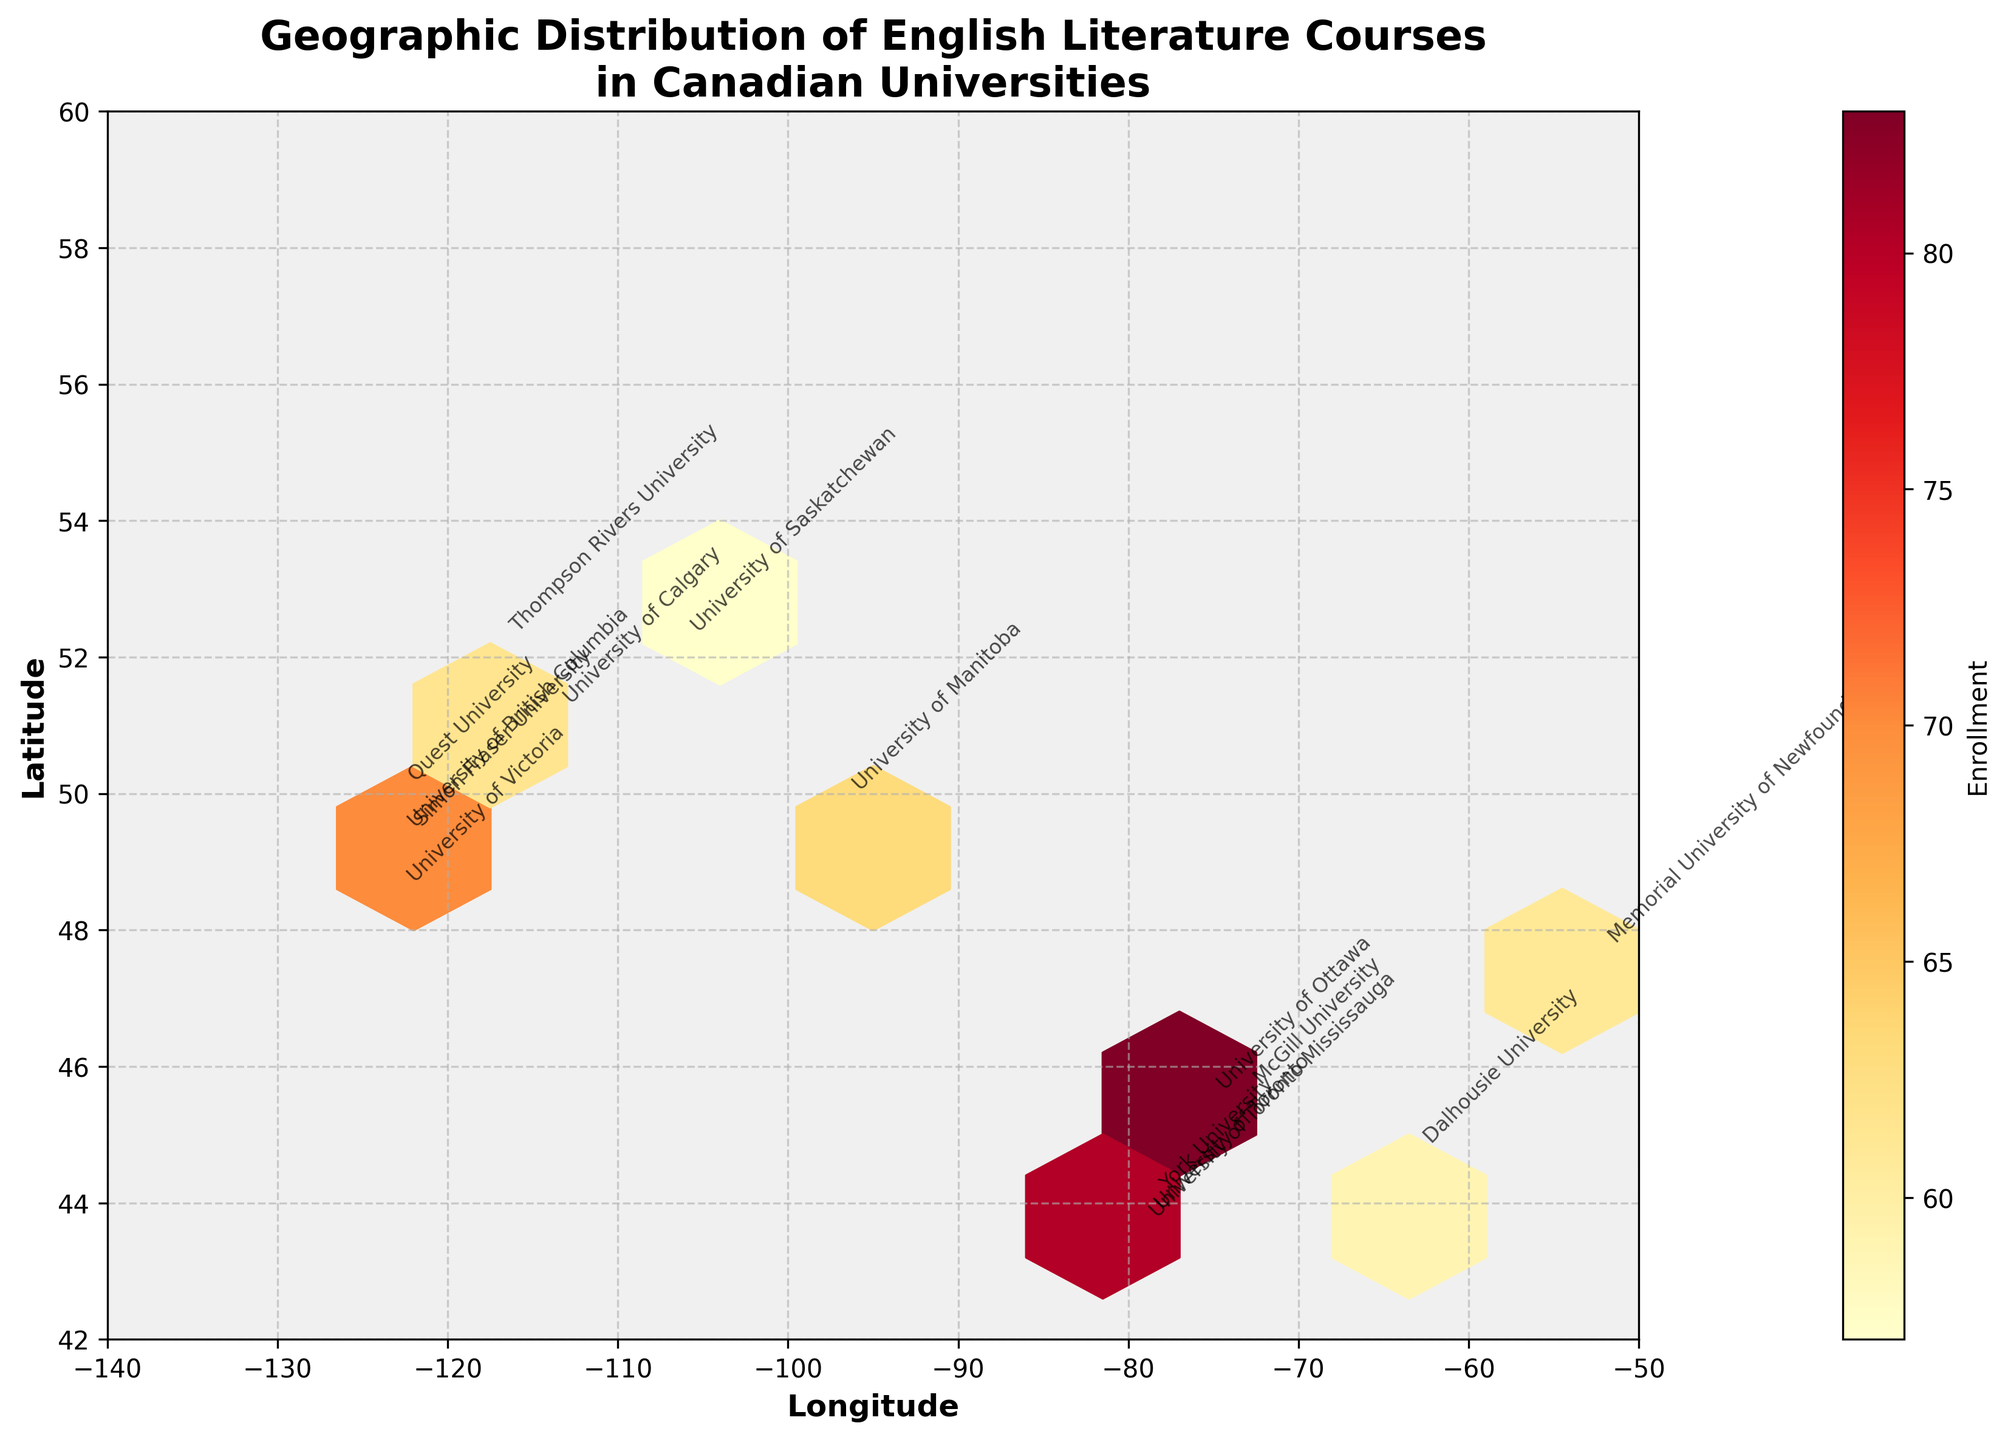What is the title of the figure? The title of a figure is typically located at the top and is usually styled to be more prominent. In this plot, the title is clearly written in bold at the top center.
Answer: Geographic Distribution of English Literature Courses in Canadian Universities How many universities are represented in the figure? The number of universities represented can be determined by counting the number of data points or annotations on the plot. Each university is uniquely annotated with its name.
Answer: 15 Which university has the highest enrollment for an English literature course? To identify the university with the highest enrollment, look for the annotation closest to the thickest hexagon, as the bin color intensity represents the enrollment number. Find the university name near the darkest red shade.
Answer: University of Toronto What is the color indicating the highest enrollment range in the color bar? The color bar provides a gradient of colors that represent different enrollment numbers. The darkest/highest color can be identified at the top end of the color bar.
Answer: Dark Red Which two universities have a similar longitude but different latitudes, and how do their enrollments compare? First, identify universities with similar longitudes by looking at the annotations along the same vertical line. Then compare their latitudes and associated enrollment numbers from the bin colors.
Answer: University of British Columbia (85) and Simon Fraser University (82) Identify a university located in the Maritime region and state its course and enrollment. The Maritime region in Canada is on the eastern coast, so check the plot's annotations around longitudes between -67 and -52. Look at the data point within that range.
Answer: Dalhousie University, Maritime Literature, 59 How does the enrollment of modernist poetry at the University of Calgary compare to the enrollment of postcolonial literature at the University of Manitoba? Identify the hexagons and corresponding annotations for University of Calgary and University of Manitoba. Compare the color intensity which represents the enrollment numbers for each university.
Answer: Modernist Poetry: 71, Postcolonial Literature: 63 What can you infer about the geographic distribution of universities offering English literature courses based on their latitude? Observe the latitudinal spread of the hexagons and annotations on the plot; note how universities distribute across different latitudinal bands.
Answer: They are mostly clustered between 43 and 50 degrees latitude Which courses have enrollments above 80, and where are they located? Look for the universities with the darkest hexagons and refer to their annotations. Then cross-reference those universities with the courses offered.
Answer: Shakespeare Studies at UBC (-123.2460, 49.2606), Modern Canadian Literature at UofT (-79.3957, 43.6629), Science Fiction Literature at SFU (-122.9123, 49.2781), Comparative World Literature at McGill (-73.5674, 45.5017) Which university located furthest to the east offers an indigenous storytelling course, and what is its enrollment? Locate the university by moving eastward (rightward) from the leftmost edge of the plot to identify the farthest right annotation offering the course in question.
Answer: University of Saskatchewan, 57 